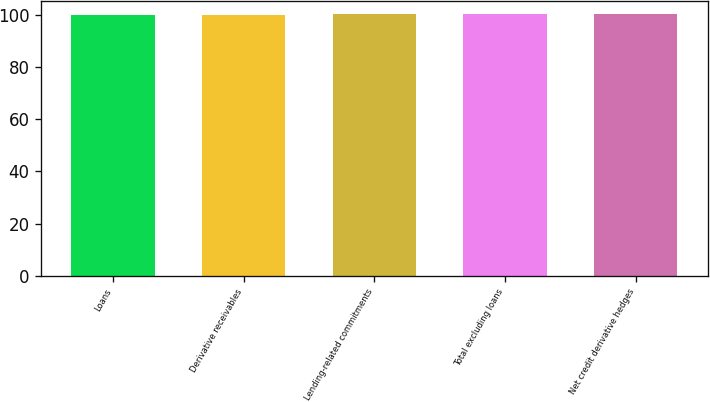Convert chart to OTSL. <chart><loc_0><loc_0><loc_500><loc_500><bar_chart><fcel>Loans<fcel>Derivative receivables<fcel>Lending-related commitments<fcel>Total excluding loans<fcel>Net credit derivative hedges<nl><fcel>100<fcel>100.1<fcel>100.2<fcel>100.3<fcel>100.4<nl></chart> 